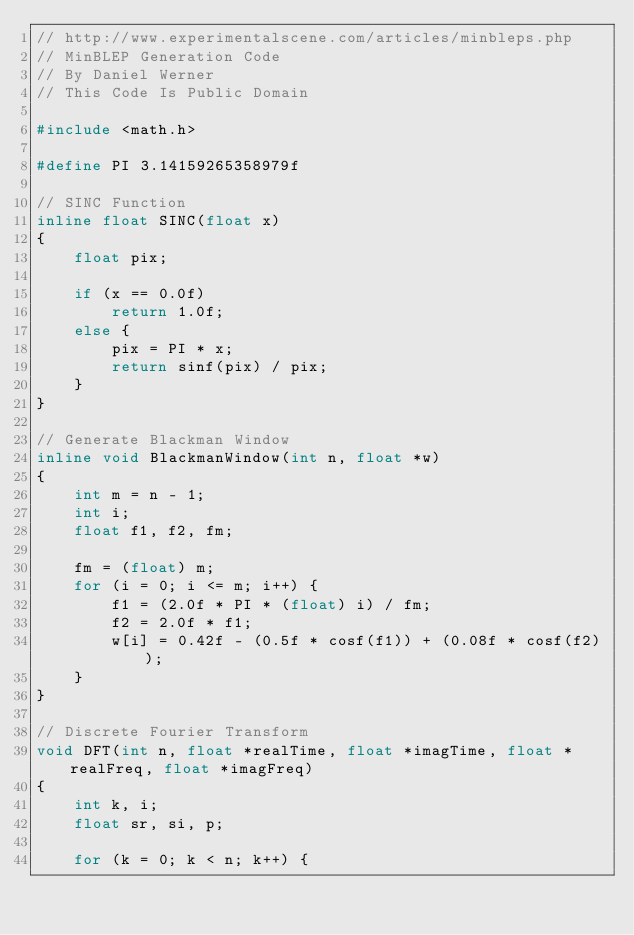<code> <loc_0><loc_0><loc_500><loc_500><_C++_>// http://www.experimentalscene.com/articles/minbleps.php
// MinBLEP Generation Code
// By Daniel Werner
// This Code Is Public Domain

#include <math.h>

#define PI 3.14159265358979f

// SINC Function
inline float SINC(float x)
{
    float pix;

    if (x == 0.0f)
        return 1.0f;
    else {
        pix = PI * x;
        return sinf(pix) / pix;
    }
}

// Generate Blackman Window
inline void BlackmanWindow(int n, float *w)
{
    int m = n - 1;
    int i;
    float f1, f2, fm;

    fm = (float) m;
    for (i = 0; i <= m; i++) {
        f1 = (2.0f * PI * (float) i) / fm;
        f2 = 2.0f * f1;
        w[i] = 0.42f - (0.5f * cosf(f1)) + (0.08f * cosf(f2));
    }
}

// Discrete Fourier Transform
void DFT(int n, float *realTime, float *imagTime, float *realFreq, float *imagFreq)
{
    int k, i;
    float sr, si, p;

    for (k = 0; k < n; k++) {</code> 